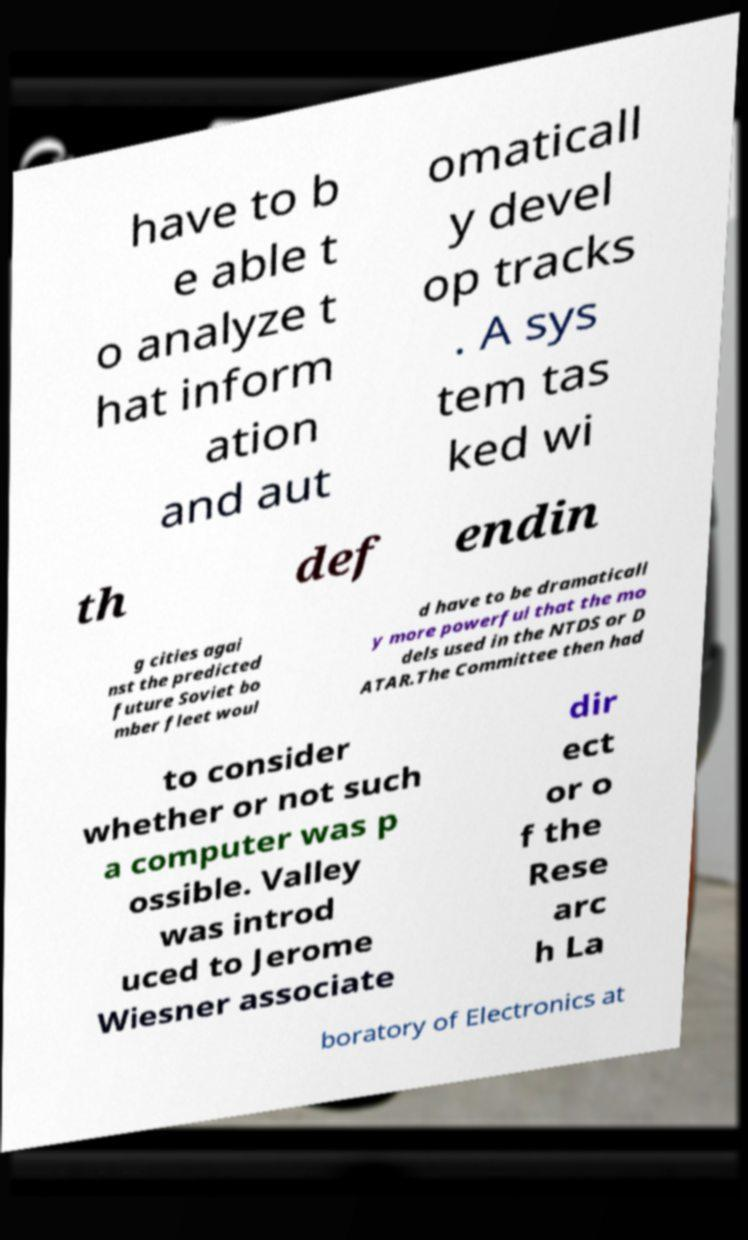What messages or text are displayed in this image? I need them in a readable, typed format. have to b e able t o analyze t hat inform ation and aut omaticall y devel op tracks . A sys tem tas ked wi th def endin g cities agai nst the predicted future Soviet bo mber fleet woul d have to be dramaticall y more powerful that the mo dels used in the NTDS or D ATAR.The Committee then had to consider whether or not such a computer was p ossible. Valley was introd uced to Jerome Wiesner associate dir ect or o f the Rese arc h La boratory of Electronics at 